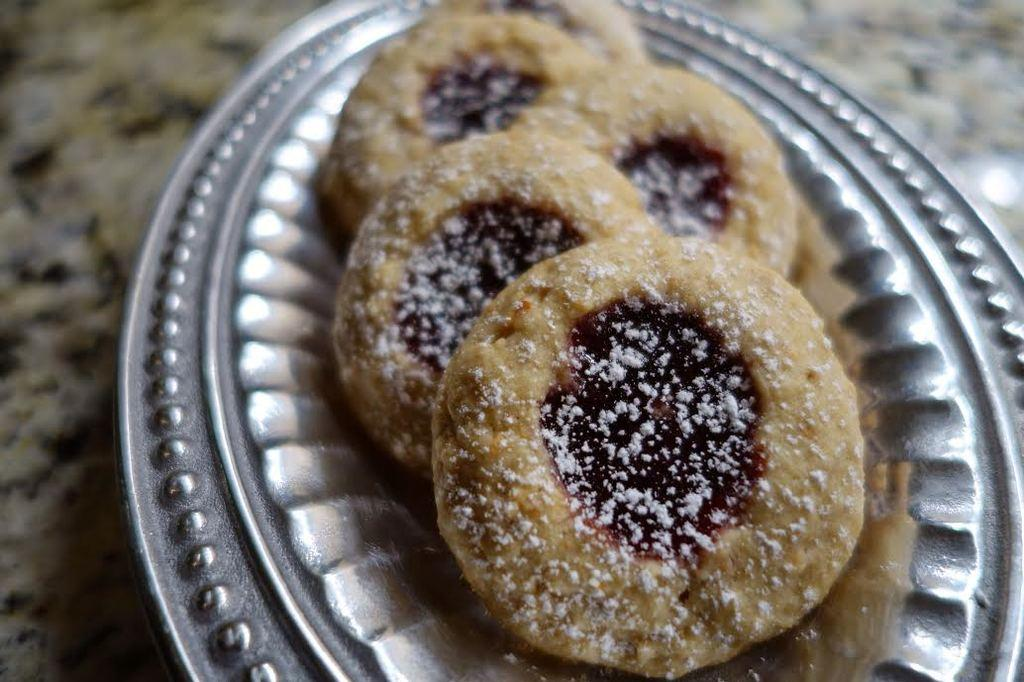What is on the plate that is visible in the image? There is food on a plate in the image. What colors can be seen in the food on the plate? The food has brown, white, and black colors. What is the color of the plate? The plate is silver in color. Where is the plate located in the image? The plate is on a surface. Can you tell me how many balloons are floating above the plate in the image? There are no balloons present in the image; it only features a plate of food with brown, white, and black colors on a silver plate. 